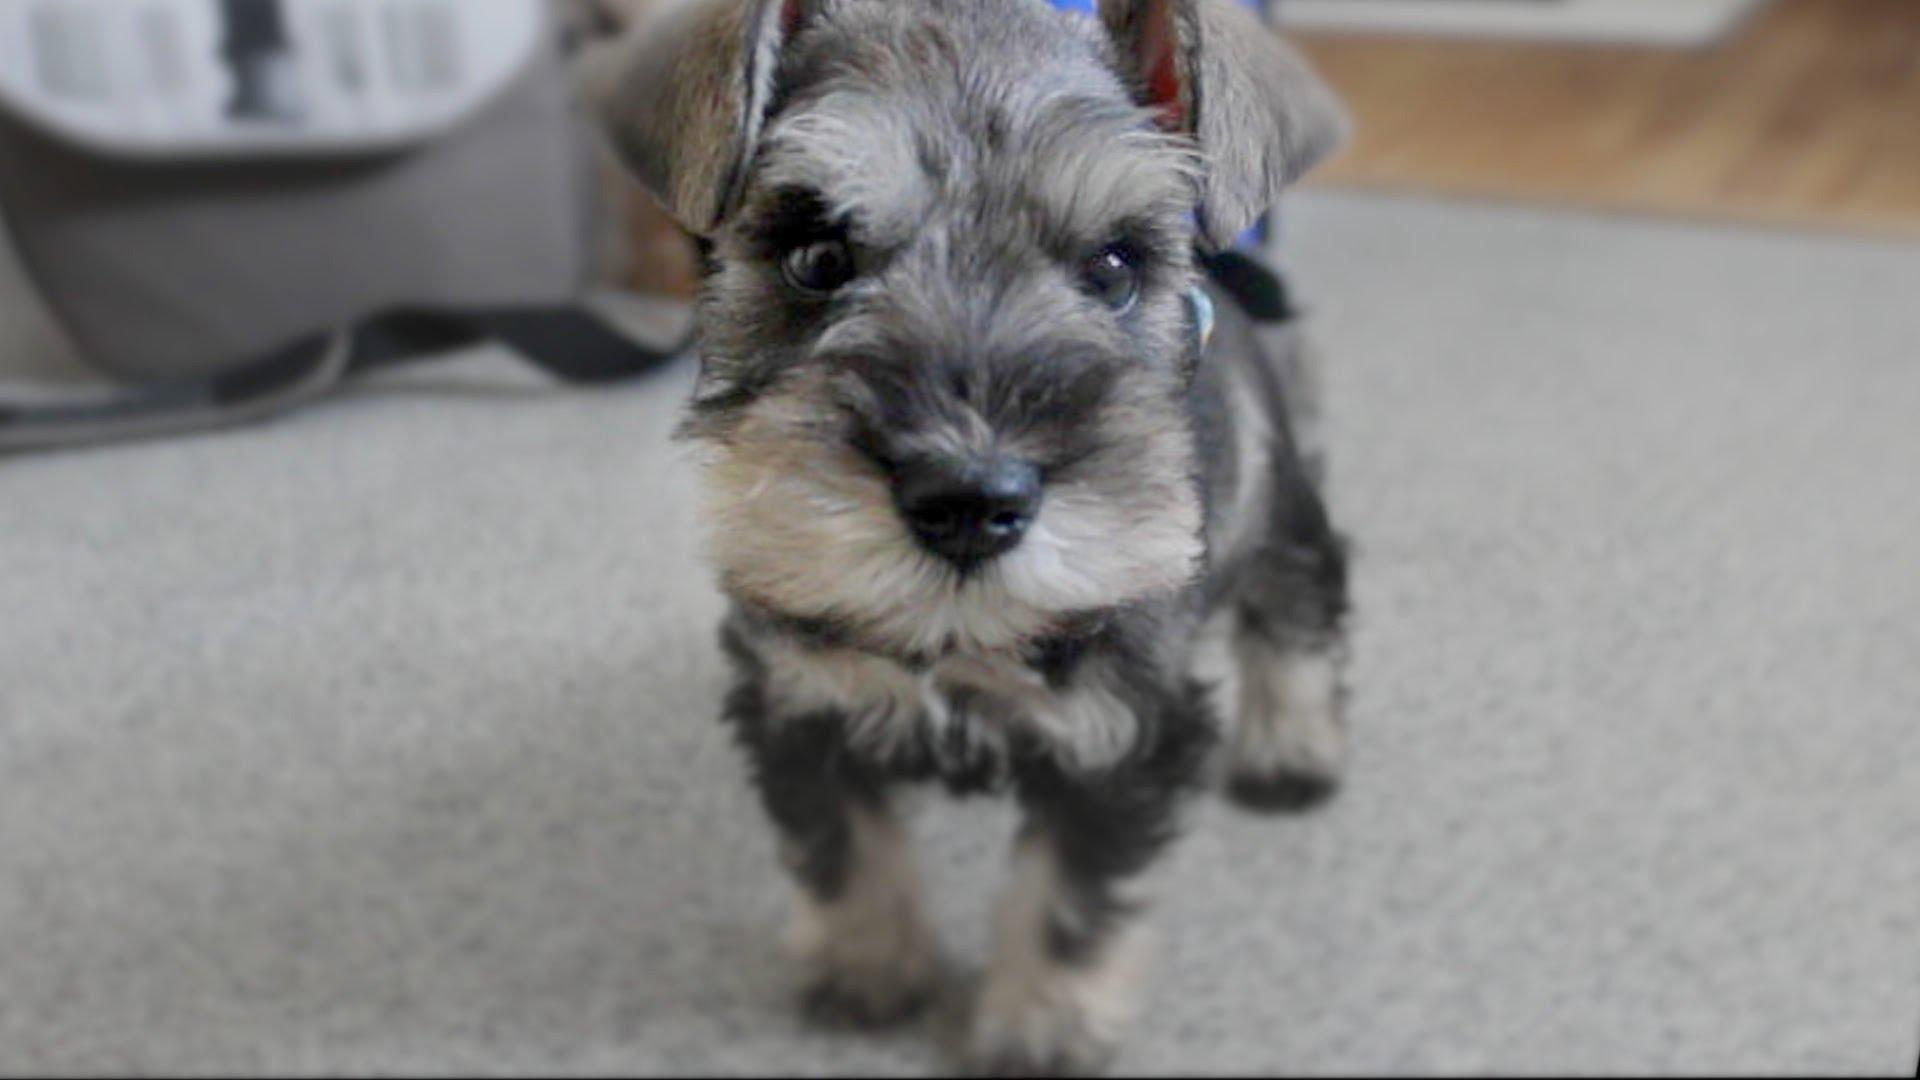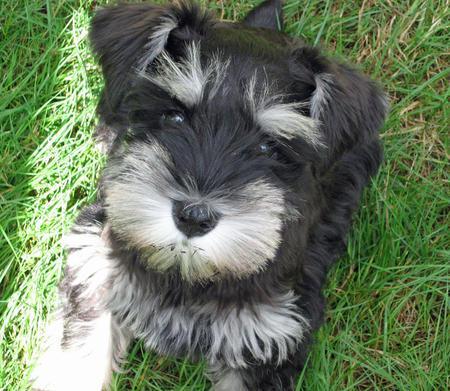The first image is the image on the left, the second image is the image on the right. For the images shown, is this caption "The dog in the right image has its mouth open as it stands in the grass." true? Answer yes or no. No. The first image is the image on the left, the second image is the image on the right. Analyze the images presented: Is the assertion "Right image shows a dog looking upward, with mouth open." valid? Answer yes or no. No. 